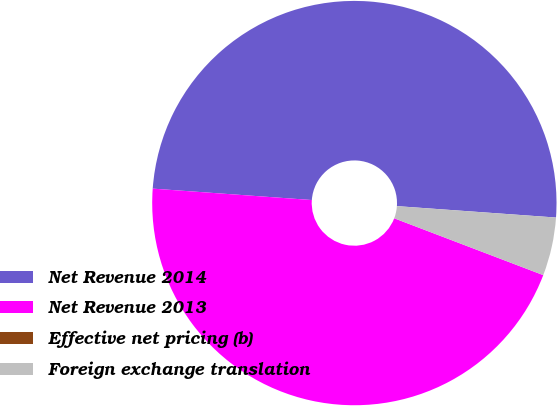Convert chart. <chart><loc_0><loc_0><loc_500><loc_500><pie_chart><fcel>Net Revenue 2014<fcel>Net Revenue 2013<fcel>Effective net pricing (b)<fcel>Foreign exchange translation<nl><fcel>50.0%<fcel>45.34%<fcel>0.0%<fcel>4.66%<nl></chart> 